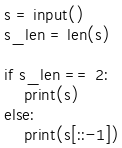Convert code to text. <code><loc_0><loc_0><loc_500><loc_500><_Python_>s = input()
s_len = len(s)

if s_len == 2:
    print(s)
else:
    print(s[::-1])</code> 